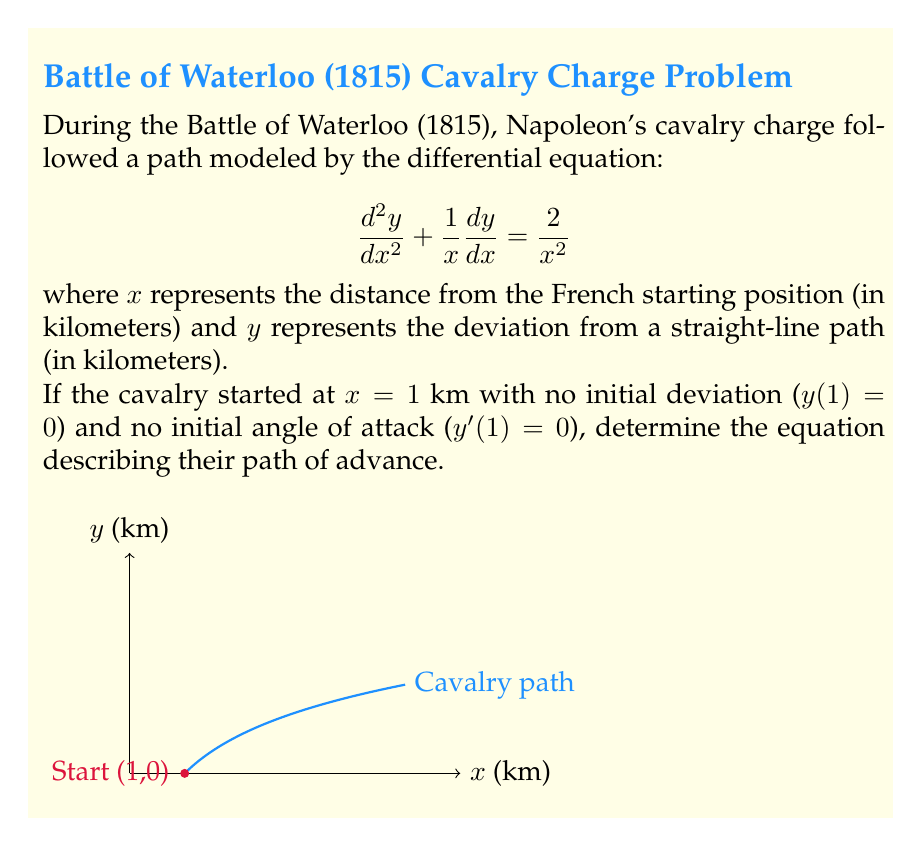Can you solve this math problem? Let's solve this step-by-step:

1) The given differential equation is:

   $$\frac{d^2y}{dx^2} + \frac{1}{x}\frac{dy}{dx} = \frac{2}{x^2}$$

2) This is a non-homogeneous second-order linear differential equation. We can solve it using the method of variation of parameters.

3) First, let's solve the homogeneous equation:

   $$\frac{d^2y}{dx^2} + \frac{1}{x}\frac{dy}{dx} = 0$$

4) This can be rewritten as:

   $$\frac{d}{dx}(x\frac{dy}{dx}) = 0$$

5) Integrating both sides:

   $$x\frac{dy}{dx} = C_1$$

   $$\frac{dy}{dx} = \frac{C_1}{x}$$

6) Integrating again:

   $$y = C_1\ln|x| + C_2$$

7) Now, let's find a particular solution. We can guess a solution of the form $y = Ax^2$:

   $$\frac{dy}{dx} = 2Ax$$
   $$\frac{d^2y}{dx^2} = 2A$$

8) Substituting into the original equation:

   $$2A + \frac{1}{x}(2Ax) = \frac{2}{x^2}$$

   $$2A + 2A = \frac{2}{x^2}$$

   $$4A = \frac{2}{x^2}$$

   $$A = \frac{1}{2x^2}$$

9) Therefore, a particular solution is:

   $$y_p = \frac{1}{2}$$

10) The general solution is the sum of the homogeneous and particular solutions:

    $$y = C_1\ln|x| + C_2 + \frac{1}{2}$$

11) Now we use the initial conditions to find $C_1$ and $C_2$:

    At $x = 1$: $y(1) = 0$, so $C_2 = -\frac{1}{2}$

    At $x = 1$: $y'(1) = 0$, so $C_1 = 0$

12) Therefore, the final solution is:

    $$y = \frac{1}{2} - \frac{1}{2} = 0$$
Answer: $y = 0$ 